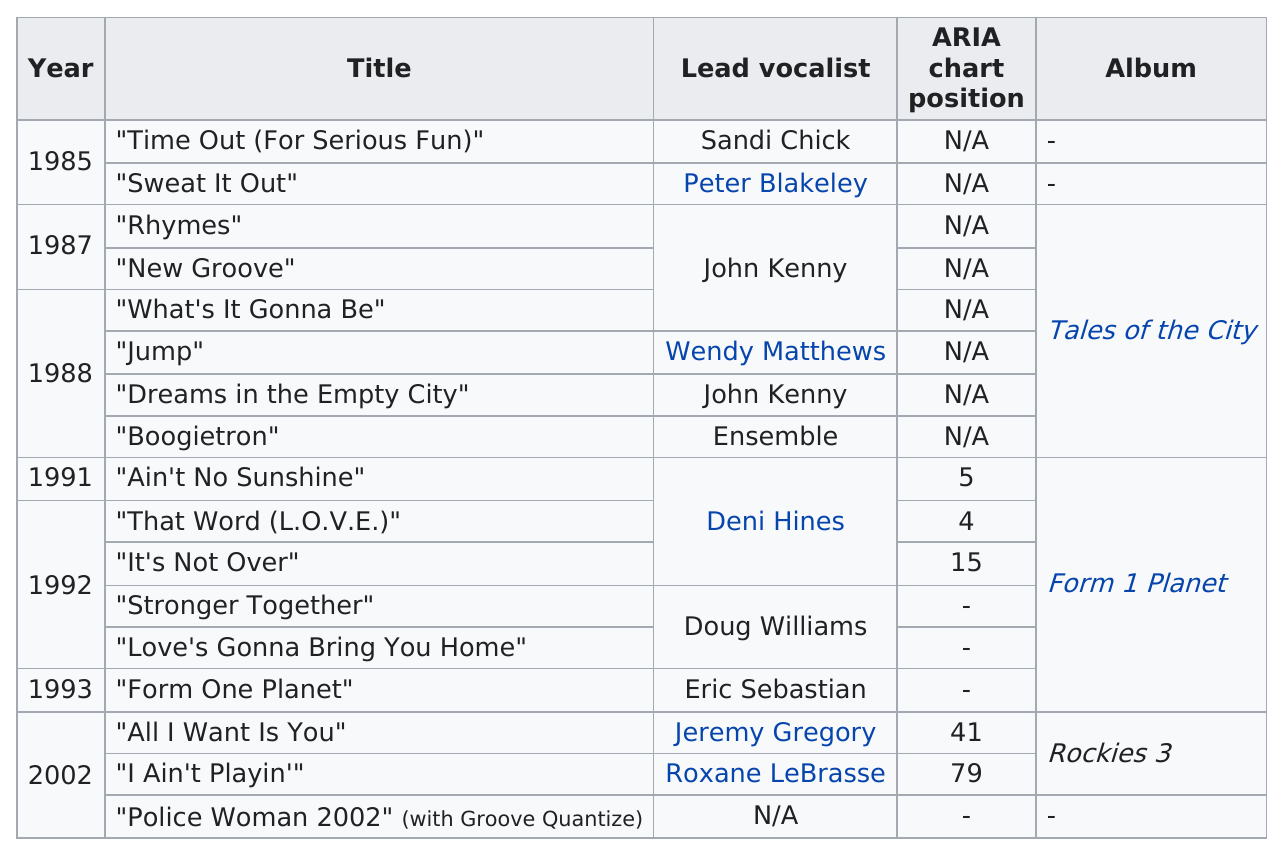List a handful of essential elements in this visual. They produced singles for 17 years. The first lead vocalist was Sandi Chick. The song "That Word (L.O.V.E.)" came next to "Ain't No Sunshine". In the year 1991, how many songs were released? That Word (L.O.V.E.)" was the song that held the highest position on the ARIA charts. 